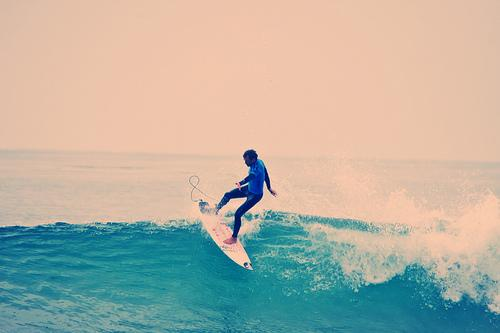Identify the primary action taking place in the image and the main object involved. A man is surfing on a white surfboard with blue fins as the wave rises. Provide three key details about the surfboard. The surfboard is white, has blue fins, and a black decal on it. What color is the surfer's shirt and what is the primary water color in the image? The surfer's shirt is blue and the primary water color is a mix of blue, grey, and white. Find the color of the item described by the phrase "this is the hand." The color information of the hand is not provided in the image. List down the surfer's outfit pieces and their colors. Blue cotton tee shirt, black rubber surf pants, and no shoes. What are the main colors present in the image and its elements? The main colors are blue, white, grey, and black in various elements like the water, surfer's outfit, and the surfboard. Describe the color of the water and the kind of splashes it has. The water is a mix of blue, grey, and white with splashy foams and ocean spray. What is the action performed by the person in the scene and how is the surfer's balance maintained? The person is sea surfing and trying to maintain balance by stretching out their arms. Explain a key detail about the ocean wave that the surfer is riding. The ocean wave is forming and splashing, with a mix of blue, grey, and white colors. What is the man doing and what is he standing on? The man is surfing in the ocean and standing on a white surfboard. 